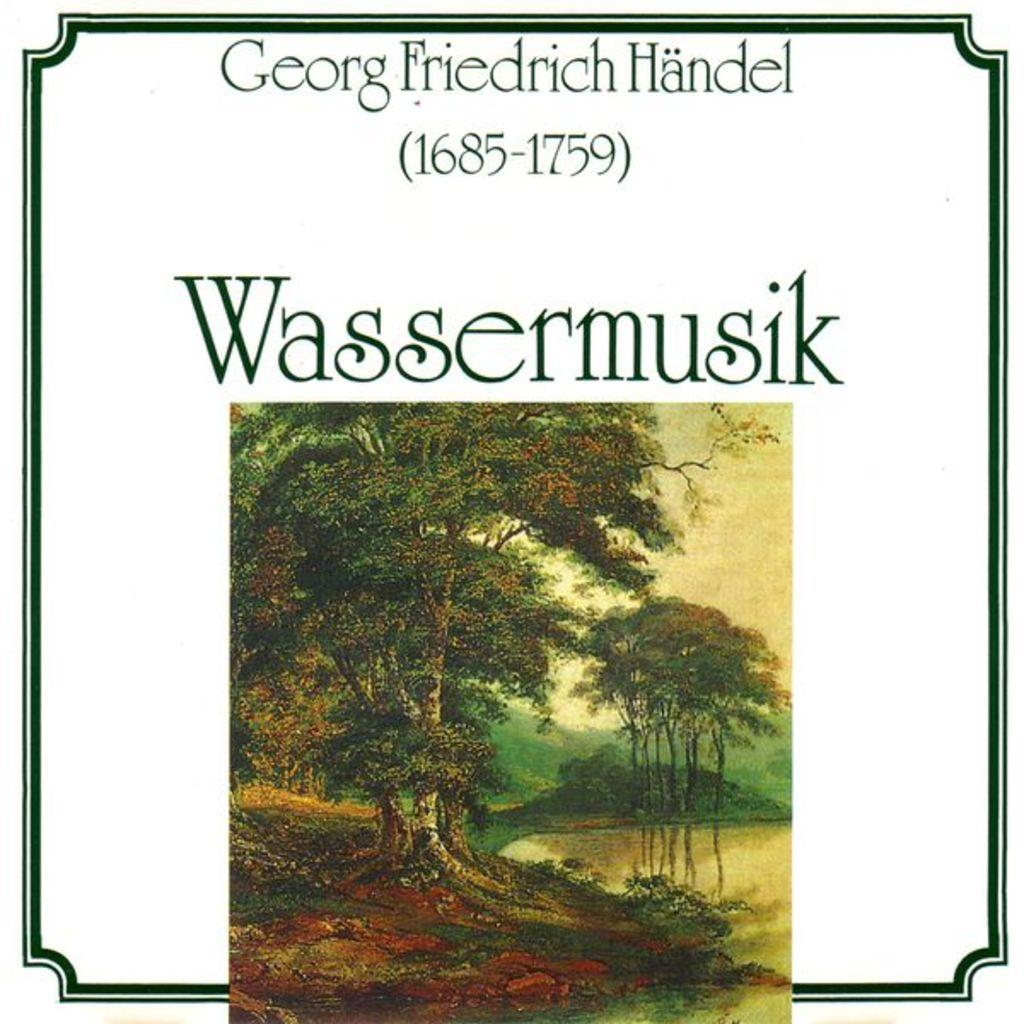What type of image is being described? The image is graphical and edited. What additional elements can be found on the image? There is text written on the image. What natural elements are present in the image? There are trees in the image. What type of liquid can be seen flowing through the trees in the image? There is no liquid flowing through the trees in the image; it is a graphical and edited image with trees depicted. 